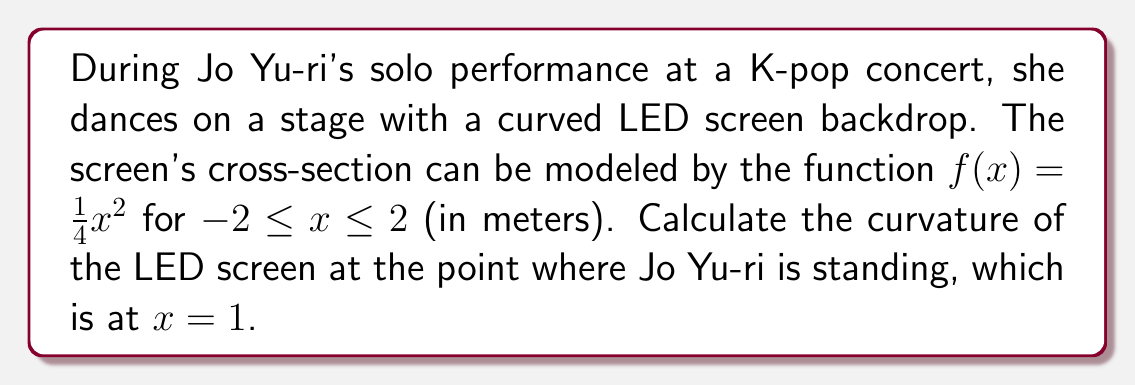Teach me how to tackle this problem. To calculate the curvature of the LED screen, we'll follow these steps:

1) The curvature $\kappa$ of a curve $y=f(x)$ is given by the formula:

   $$\kappa = \frac{|f''(x)|}{(1+[f'(x)]^2)^{3/2}}$$

2) First, we need to find $f'(x)$ and $f''(x)$:
   
   $f(x) = \frac{1}{4}x^2$
   $f'(x) = \frac{1}{2}x$
   $f''(x) = \frac{1}{2}$

3) Now, let's evaluate $f'(x)$ at $x=1$:
   
   $f'(1) = \frac{1}{2}(1) = \frac{1}{2}$

4) We know that $f''(x)$ is constant, so $f''(1) = \frac{1}{2}$

5) Now we can substitute these values into the curvature formula:

   $$\kappa = \frac{|\frac{1}{2}|}{(1+[\frac{1}{2}]^2)^{3/2}}$$

6) Simplify:
   $$\kappa = \frac{0.5}{(1+0.25)^{3/2}} = \frac{0.5}{1.25^{3/2}} = \frac{0.5}{1.397} \approx 0.358$$

Therefore, the curvature of the LED screen at the point where Jo Yu-ri is standing $(x=1)$ is approximately 0.358 m^(-1).
Answer: $\kappa \approx 0.358$ m^(-1) 